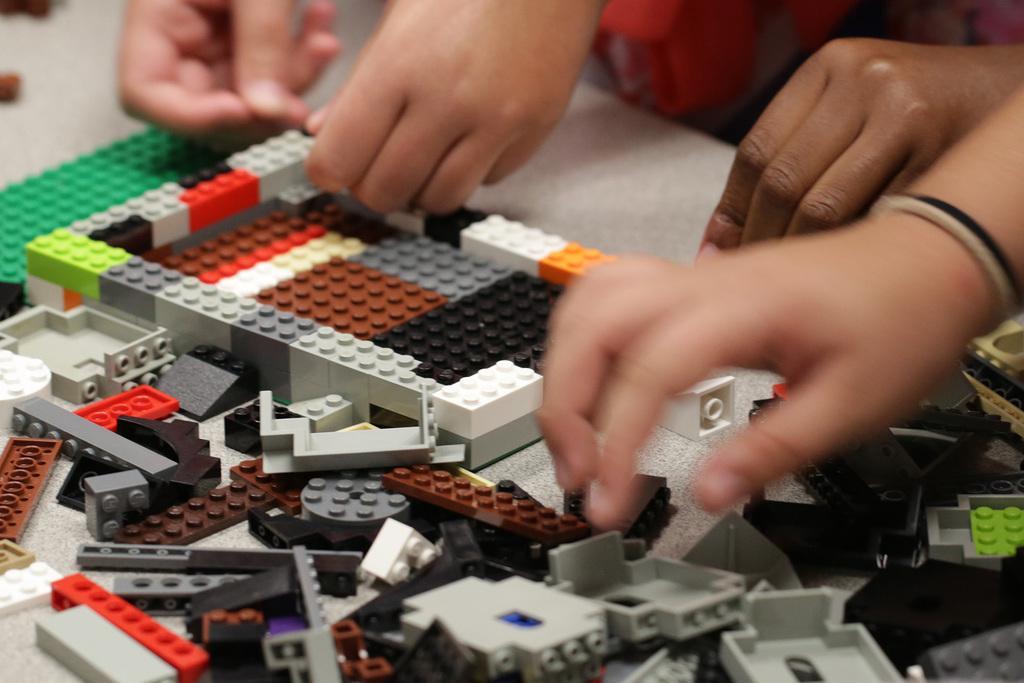Could you give a brief overview of what you see in this image? In the middle of the image there are many building blocks on the table. At the top of the image a few kids are holding building blocks in their hands. 